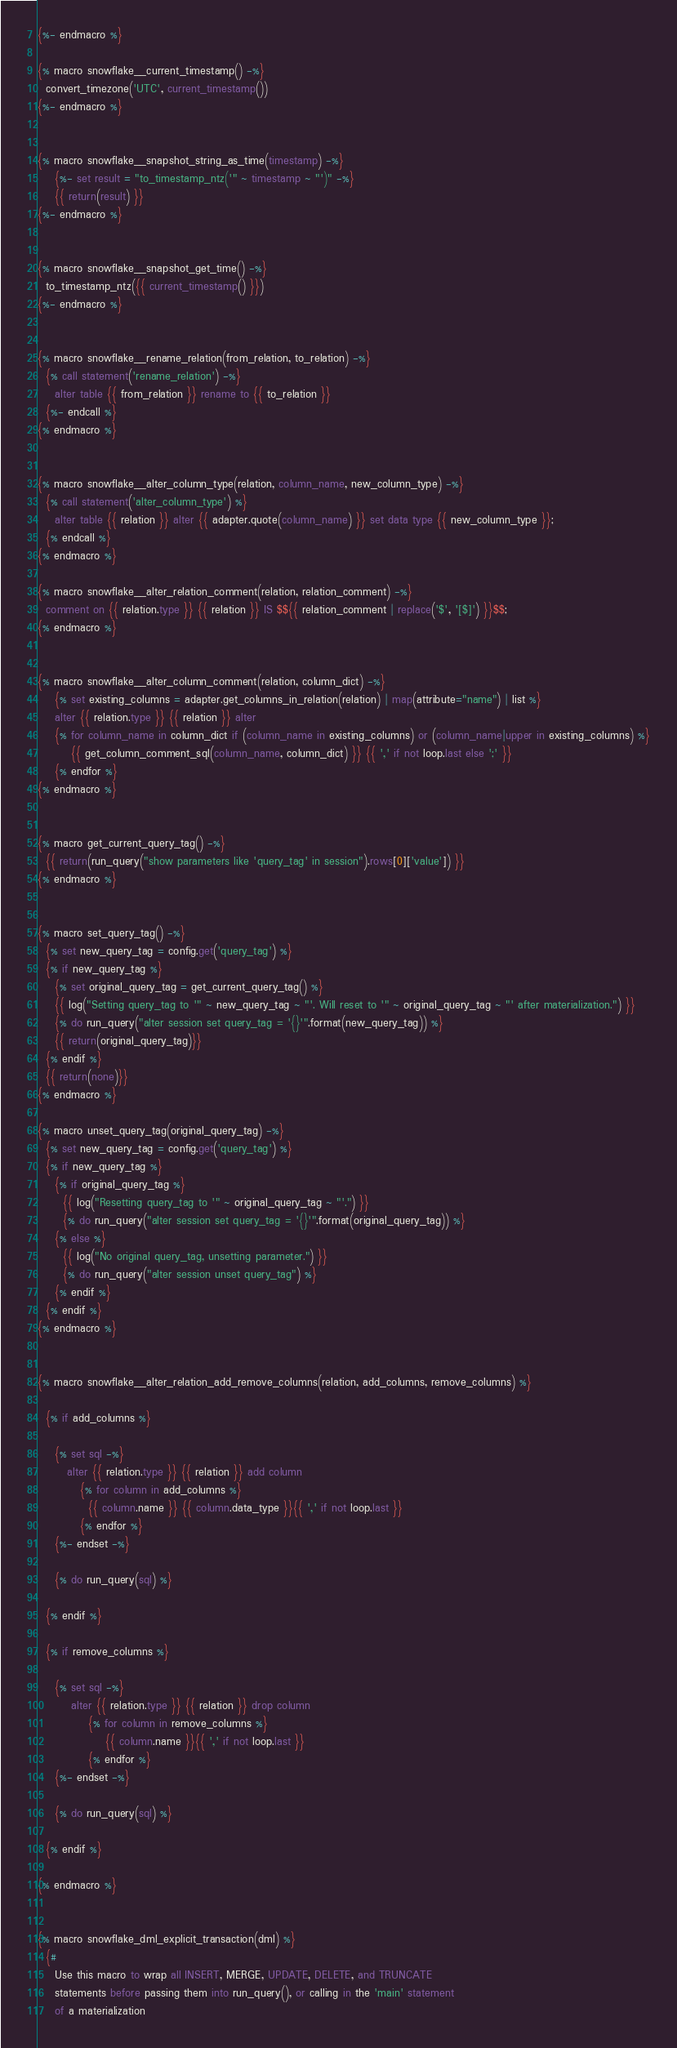<code> <loc_0><loc_0><loc_500><loc_500><_SQL_>{%- endmacro %}

{% macro snowflake__current_timestamp() -%}
  convert_timezone('UTC', current_timestamp())
{%- endmacro %}


{% macro snowflake__snapshot_string_as_time(timestamp) -%}
    {%- set result = "to_timestamp_ntz('" ~ timestamp ~ "')" -%}
    {{ return(result) }}
{%- endmacro %}


{% macro snowflake__snapshot_get_time() -%}
  to_timestamp_ntz({{ current_timestamp() }})
{%- endmacro %}


{% macro snowflake__rename_relation(from_relation, to_relation) -%}
  {% call statement('rename_relation') -%}
    alter table {{ from_relation }} rename to {{ to_relation }}
  {%- endcall %}
{% endmacro %}


{% macro snowflake__alter_column_type(relation, column_name, new_column_type) -%}
  {% call statement('alter_column_type') %}
    alter table {{ relation }} alter {{ adapter.quote(column_name) }} set data type {{ new_column_type }};
  {% endcall %}
{% endmacro %}

{% macro snowflake__alter_relation_comment(relation, relation_comment) -%}
  comment on {{ relation.type }} {{ relation }} IS $${{ relation_comment | replace('$', '[$]') }}$$;
{% endmacro %}


{% macro snowflake__alter_column_comment(relation, column_dict) -%}
    {% set existing_columns = adapter.get_columns_in_relation(relation) | map(attribute="name") | list %}
    alter {{ relation.type }} {{ relation }} alter
    {% for column_name in column_dict if (column_name in existing_columns) or (column_name|upper in existing_columns) %}
        {{ get_column_comment_sql(column_name, column_dict) }} {{ ',' if not loop.last else ';' }}
    {% endfor %}
{% endmacro %}


{% macro get_current_query_tag() -%}
  {{ return(run_query("show parameters like 'query_tag' in session").rows[0]['value']) }}
{% endmacro %}


{% macro set_query_tag() -%}
  {% set new_query_tag = config.get('query_tag') %}
  {% if new_query_tag %}
    {% set original_query_tag = get_current_query_tag() %}
    {{ log("Setting query_tag to '" ~ new_query_tag ~ "'. Will reset to '" ~ original_query_tag ~ "' after materialization.") }}
    {% do run_query("alter session set query_tag = '{}'".format(new_query_tag)) %}
    {{ return(original_query_tag)}}
  {% endif %}
  {{ return(none)}}
{% endmacro %}

{% macro unset_query_tag(original_query_tag) -%}
  {% set new_query_tag = config.get('query_tag') %}
  {% if new_query_tag %}
    {% if original_query_tag %}
      {{ log("Resetting query_tag to '" ~ original_query_tag ~ "'.") }}
      {% do run_query("alter session set query_tag = '{}'".format(original_query_tag)) %}
    {% else %}
      {{ log("No original query_tag, unsetting parameter.") }}
      {% do run_query("alter session unset query_tag") %}
    {% endif %}
  {% endif %}
{% endmacro %} 


{% macro snowflake__alter_relation_add_remove_columns(relation, add_columns, remove_columns) %}
  
  {% if add_columns %}
    
    {% set sql -%}
       alter {{ relation.type }} {{ relation }} add column
          {% for column in add_columns %}
            {{ column.name }} {{ column.data_type }}{{ ',' if not loop.last }}
          {% endfor %}
    {%- endset -%}

    {% do run_query(sql) %}

  {% endif %}

  {% if remove_columns %}
  
    {% set sql -%}
        alter {{ relation.type }} {{ relation }} drop column
            {% for column in remove_columns %}
                {{ column.name }}{{ ',' if not loop.last }}
            {% endfor %}
    {%- endset -%}
    
    {% do run_query(sql) %}
    
  {% endif %}

{% endmacro %}


{% macro snowflake_dml_explicit_transaction(dml) %}
  {#
    Use this macro to wrap all INSERT, MERGE, UPDATE, DELETE, and TRUNCATE 
    statements before passing them into run_query(), or calling in the 'main' statement
    of a materialization</code> 